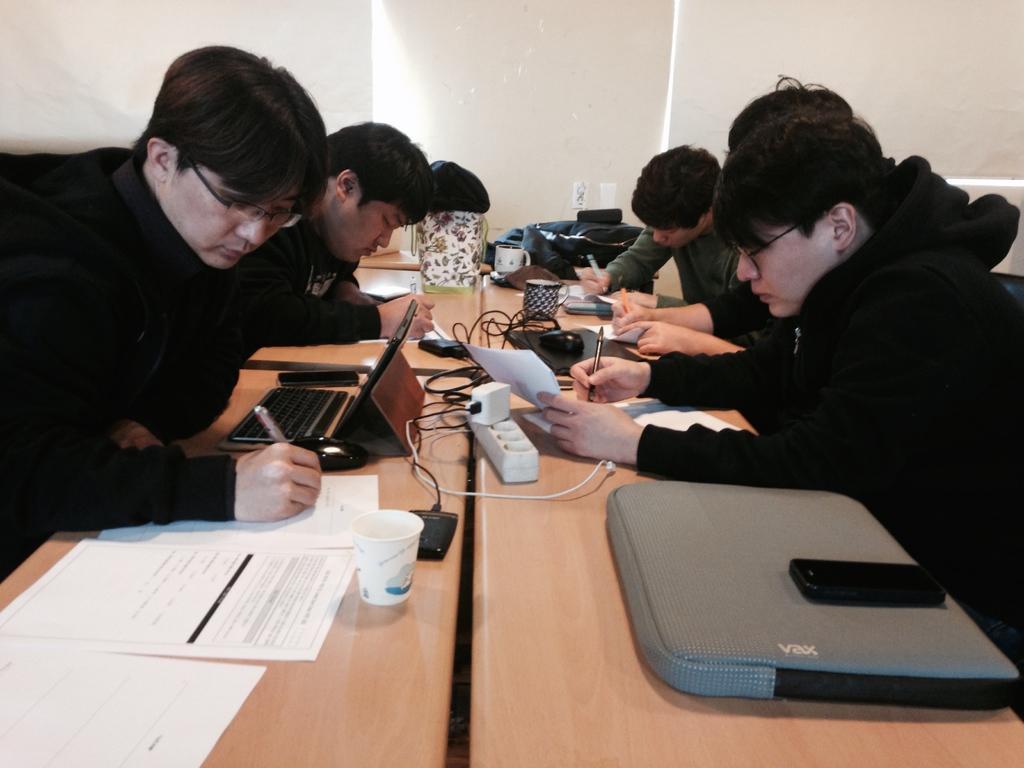Could you give a brief overview of what you see in this image? To the left side on the table there are few papers. There is a man sitting in front of the table and writing something on the paper. On the table there are laptop, mobile, charger and cup. Beside him there is another man sitting and writing. To the right corner of the image there is a man with black jacket is sitting and writing on the paper. On the table to the bottom corner there is a bag with mobile on it. Behind him there are few people sitting. And on the table there are few items like cup, wire, charger and plug box. To the top of the image there is a white wall. 